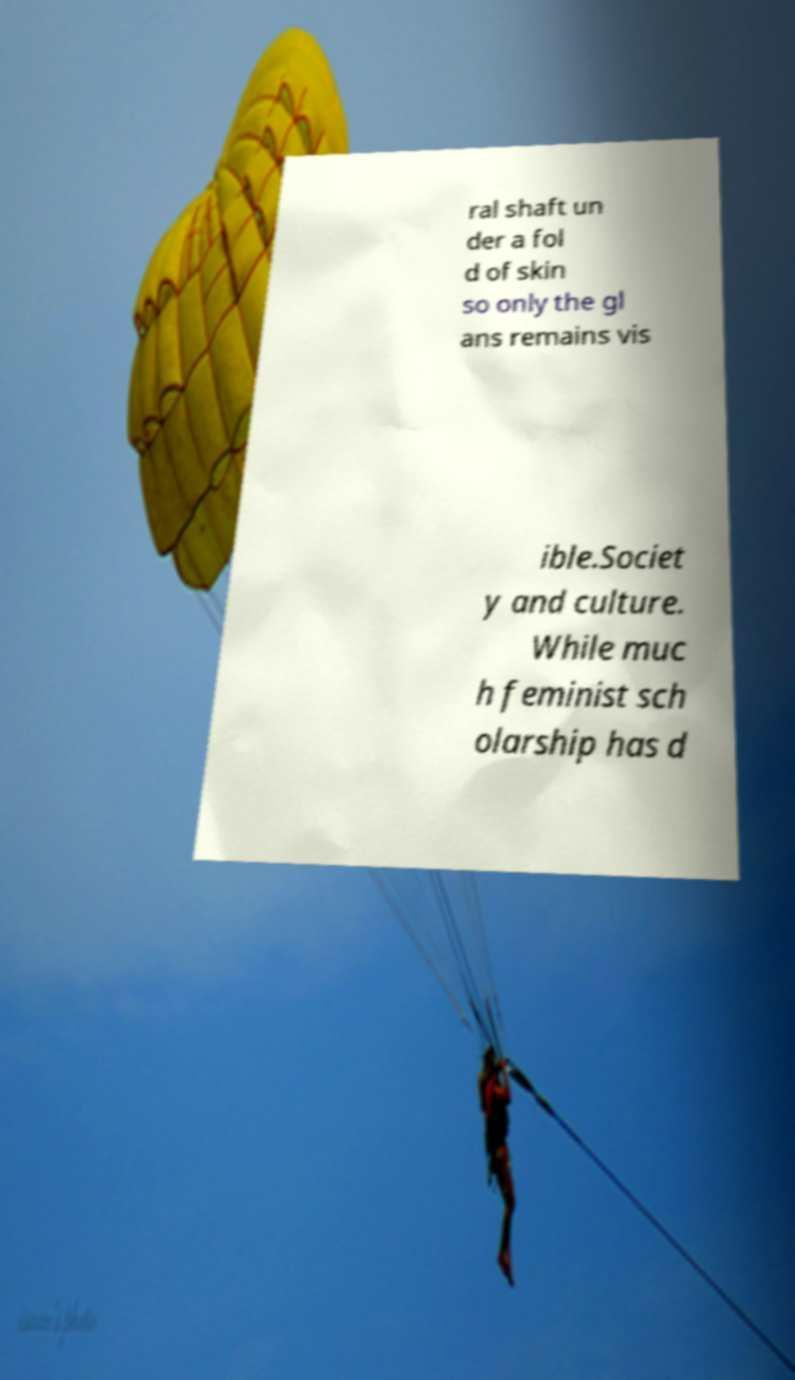Please read and relay the text visible in this image. What does it say? ral shaft un der a fol d of skin so only the gl ans remains vis ible.Societ y and culture. While muc h feminist sch olarship has d 